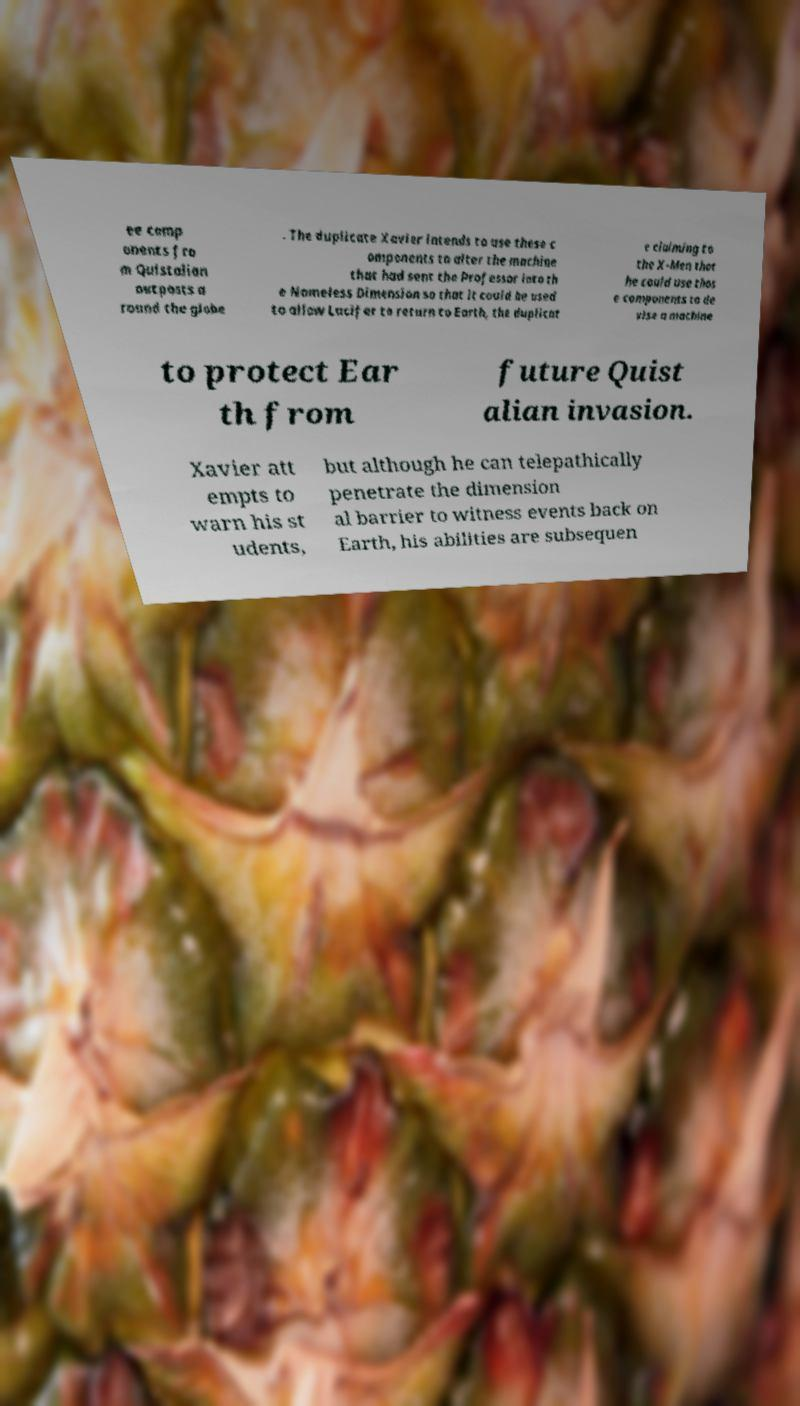Please identify and transcribe the text found in this image. ee comp onents fro m Quistalian outposts a round the globe . The duplicate Xavier intends to use these c omponents to alter the machine that had sent the Professor into th e Nameless Dimension so that it could be used to allow Lucifer to return to Earth, the duplicat e claiming to the X-Men that he could use thos e components to de vise a machine to protect Ear th from future Quist alian invasion. Xavier att empts to warn his st udents, but although he can telepathically penetrate the dimension al barrier to witness events back on Earth, his abilities are subsequen 